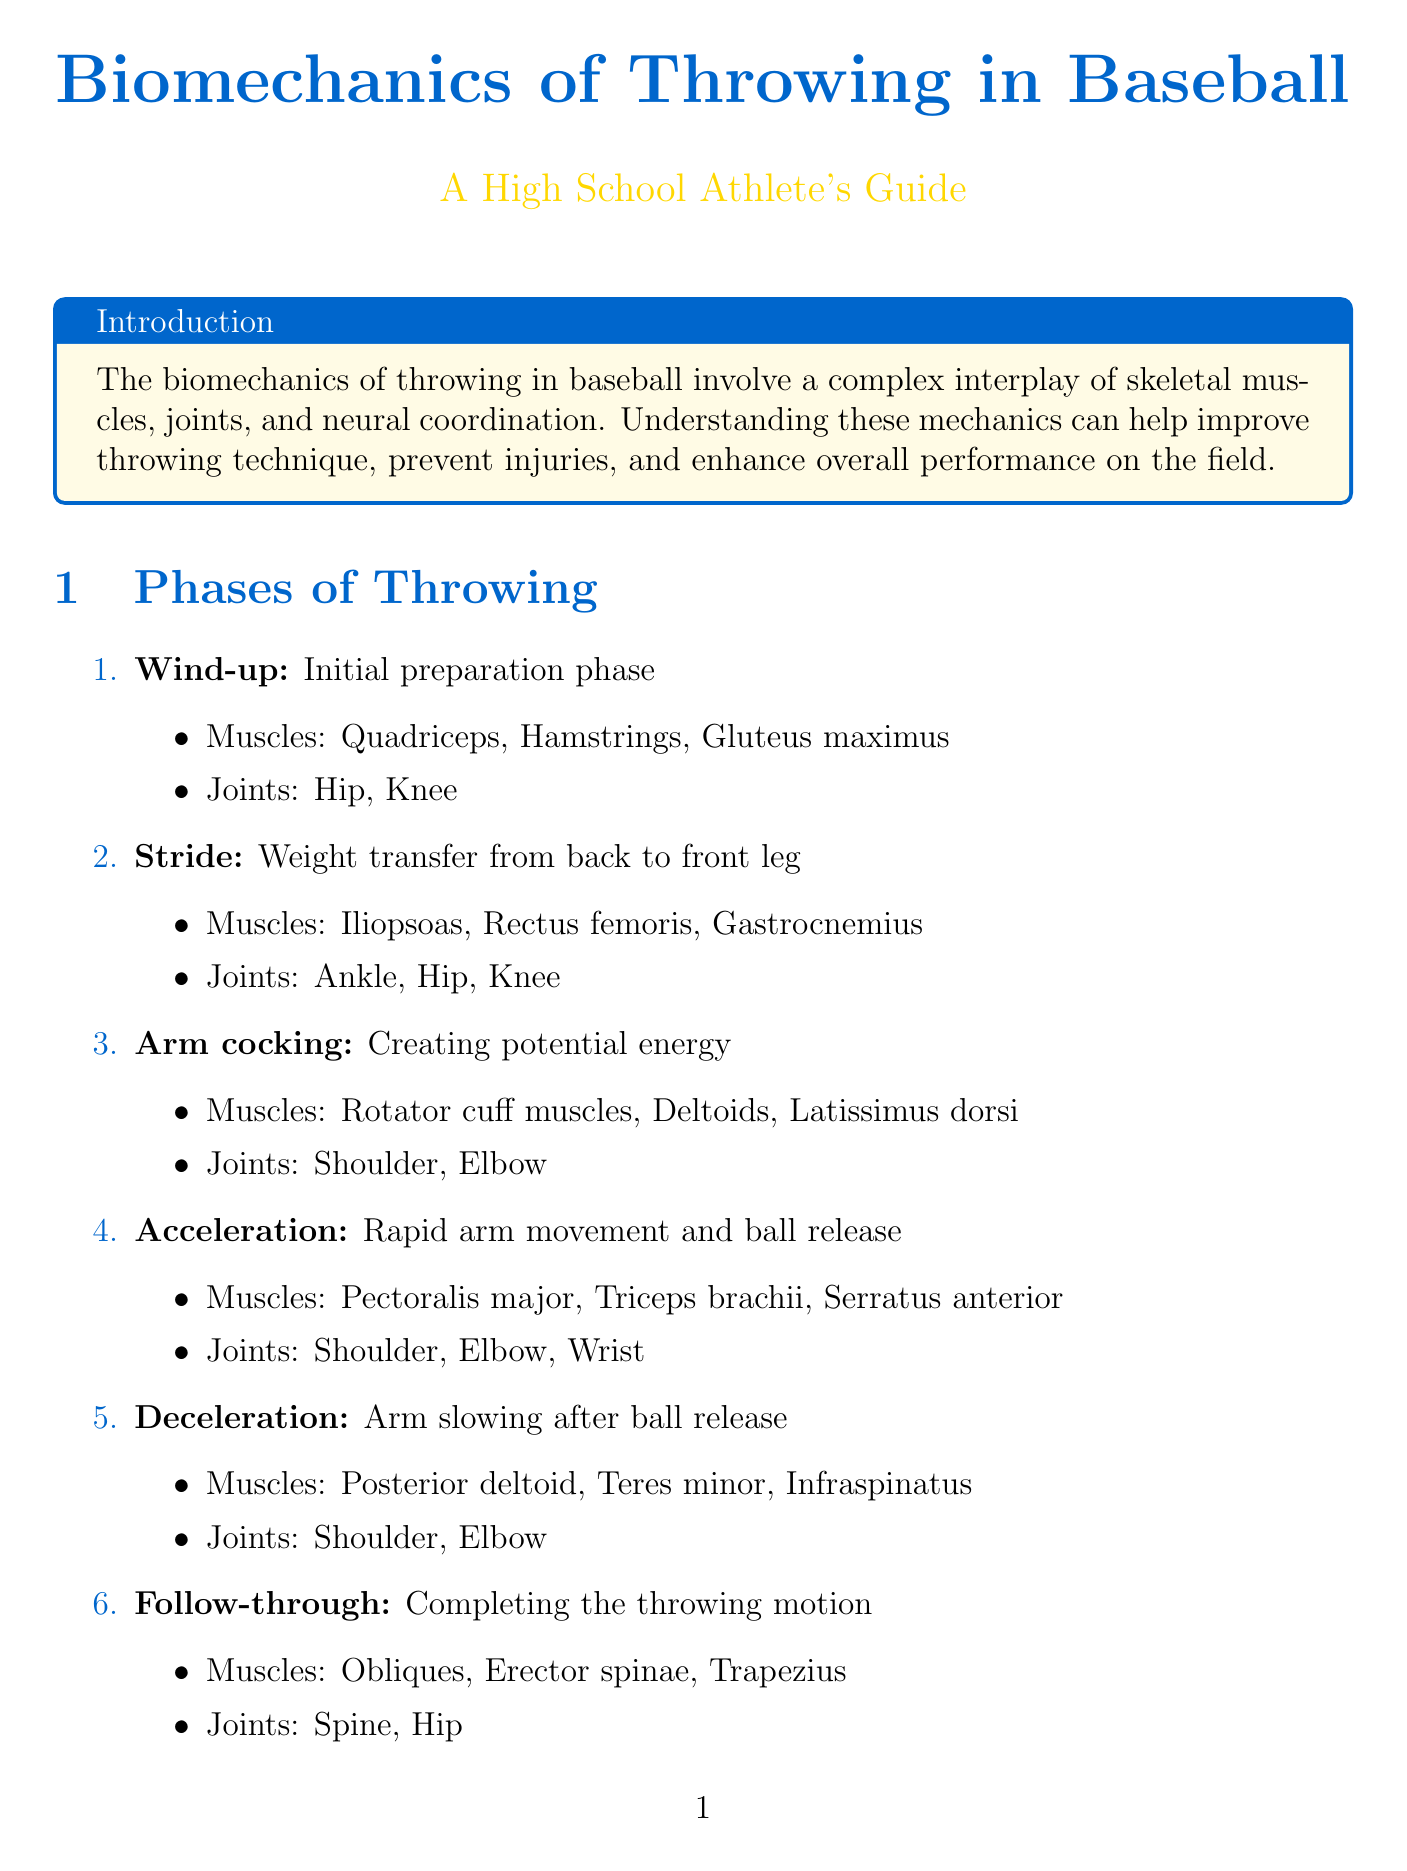what is the purpose of understanding biomechanics in baseball? The document states that understanding these mechanics can help improve throwing technique, prevent injuries, and enhance overall performance on the field.
Answer: improve throwing technique, prevent injuries, enhance performance what muscle is essential for generating ball speed during acceleration? The document identifies the Triceps brachii as essential for generating ball speed during arm acceleration.
Answer: Triceps brachii which phase involves weight transfer from back to front leg? The Stride phase describes the action of stepping forward and transferring weight.
Answer: Stride how many key phases of throwing are described in the document? The document outlines six key phases of throwing in baseball.
Answer: six which joint undergoes external rotation during the arm cocking phase? The document states that the Shoulder joint experiences external rotation during the arm cocking phase.
Answer: Shoulder what is a common injury mentioned related to throwing in baseball? The document lists common injuries including Rotator cuff tears, UCL sprains, and Labral tears.
Answer: Rotator cuff tears what biomechanical principle relates to energy transfer from legs through trunk to arm? The Kinetic chain is the principle that explains energy transfer from the legs through the trunk to the arm.
Answer: Kinetic chain which technological advancement helps analyze throwing mechanics in detail? 3D motion capture is the technological advancement mentioned for analyzing throwing mechanics.
Answer: 3D motion capture what is a recommended strategy for injury prevention outlined in the document? The document suggests maintaining proper throwing mechanics as a strategy for injury prevention.
Answer: maintaining proper throwing mechanics 